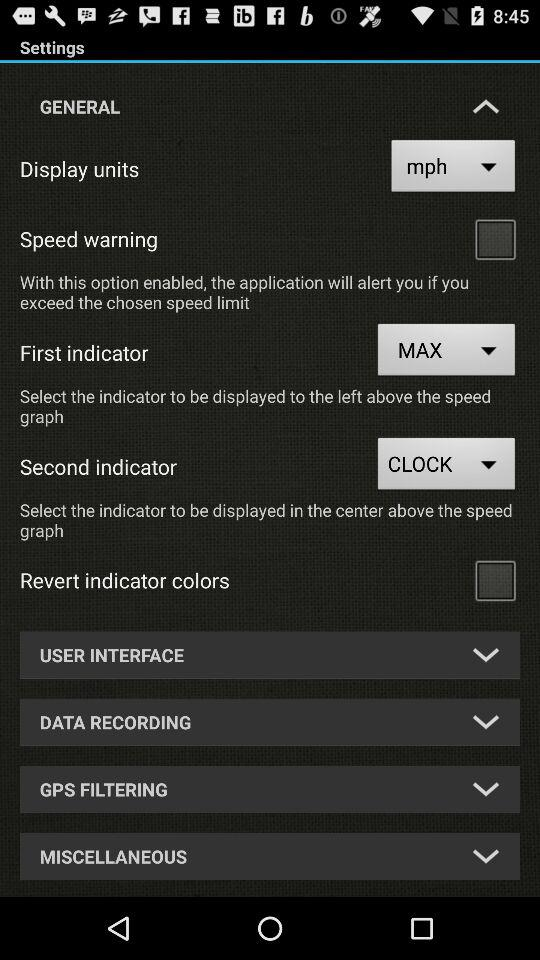Is "Speed warning" checked or unchecked? "Speed warning" is unchecked. 